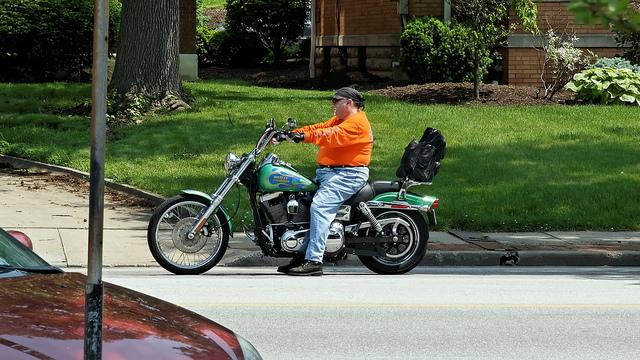What is on the back of the motorcycle? backpack 